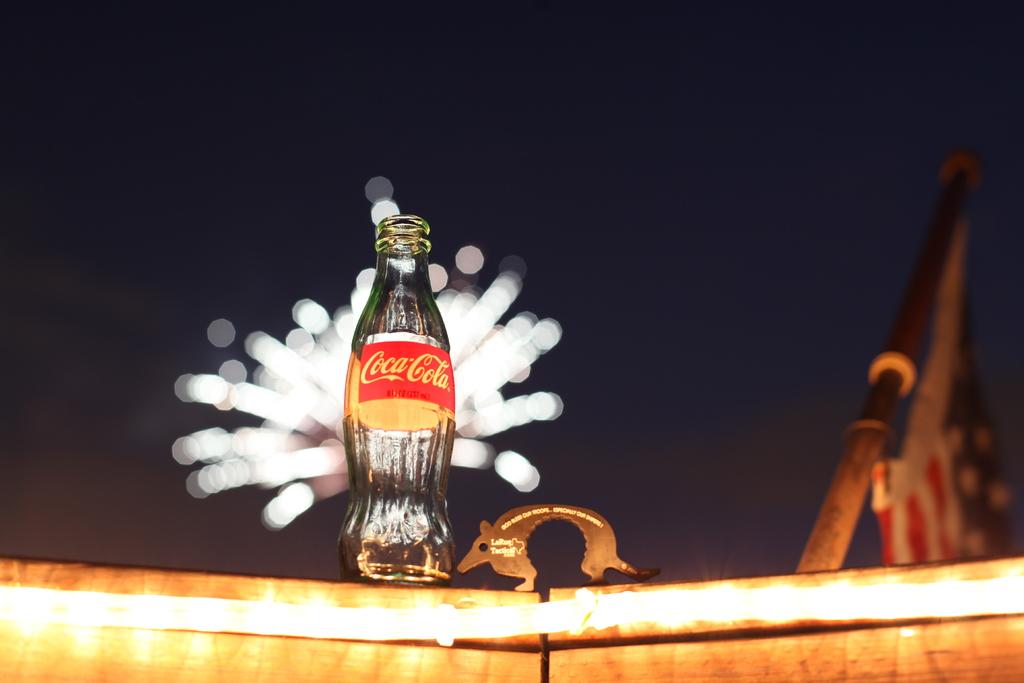What was in the bottle?
Your answer should be compact. Coca cola. What brand was this soda?
Make the answer very short. Coca cola. 